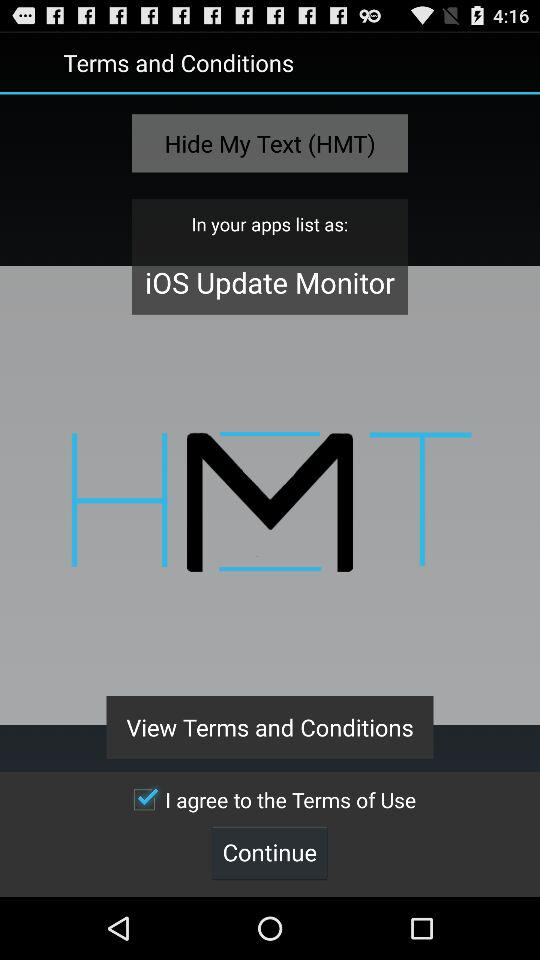What is the status of "I agree to the Terms of Use"? The status is "on". 